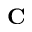<formula> <loc_0><loc_0><loc_500><loc_500>C</formula> 